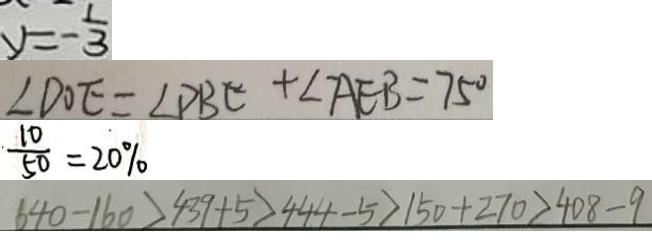Convert formula to latex. <formula><loc_0><loc_0><loc_500><loc_500>y = - \frac { 1 } { 3 } 
 \angle D O E = \angle P B C + \angle A E B = 7 5 ^ { \circ } 
 \frac { 1 0 } { 5 0 } = 2 0 \% 
 6 4 0 - 1 6 0 > 4 3 9 + 5 > 4 4 4 - 5 > 1 5 0 + 2 7 0 > 4 0 8 - 9</formula> 